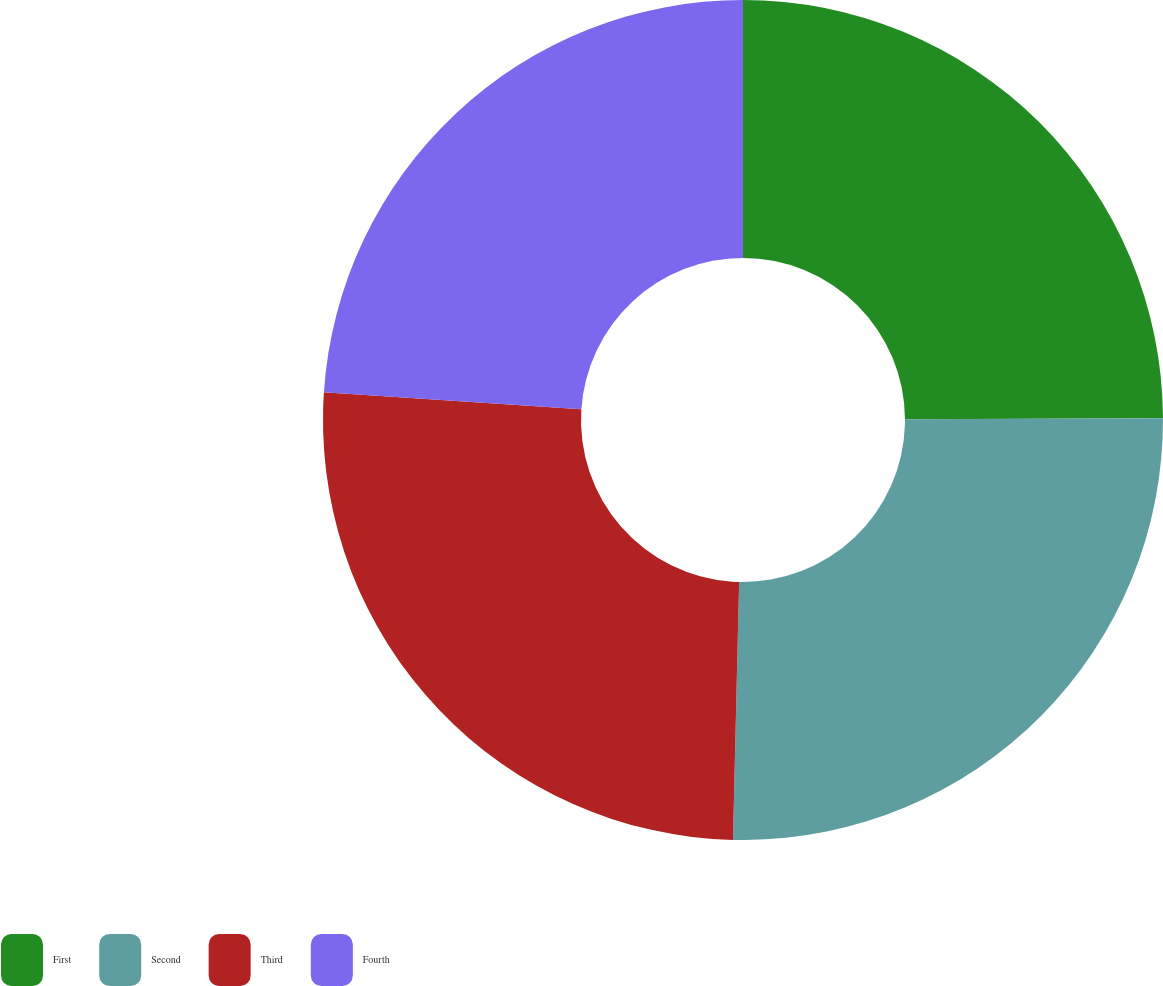<chart> <loc_0><loc_0><loc_500><loc_500><pie_chart><fcel>First<fcel>Second<fcel>Third<fcel>Fourth<nl><fcel>24.93%<fcel>25.45%<fcel>25.67%<fcel>23.95%<nl></chart> 